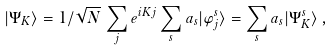Convert formula to latex. <formula><loc_0><loc_0><loc_500><loc_500>| \Psi _ { K } \rangle = 1 / \sqrt { N } \, \sum _ { j } e ^ { i K j } \sum _ { s } a _ { s } | \varphi _ { j } ^ { s } \rangle = \sum _ { s } a _ { s } | \Psi _ { K } ^ { s } \rangle \, ,</formula> 